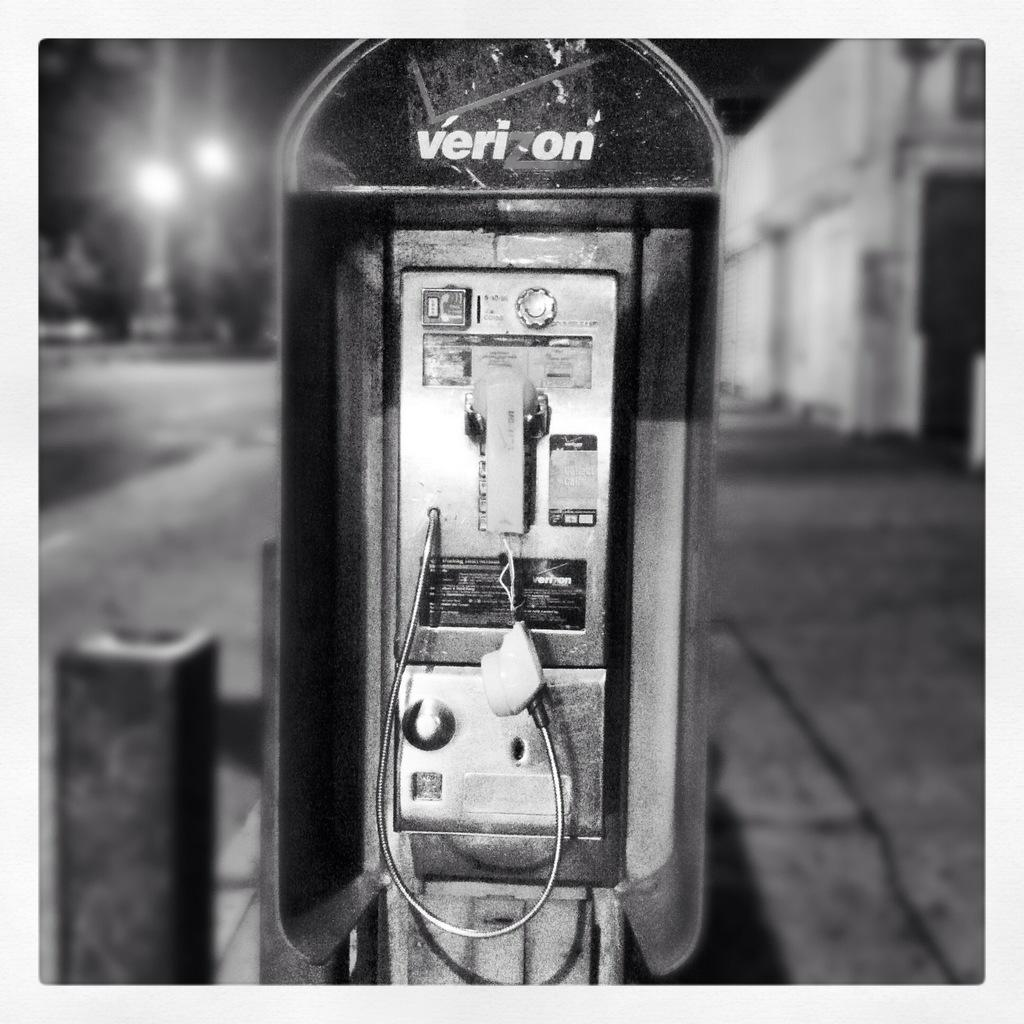<image>
Present a compact description of the photo's key features. A payphone that is broken from the brand verizon. 